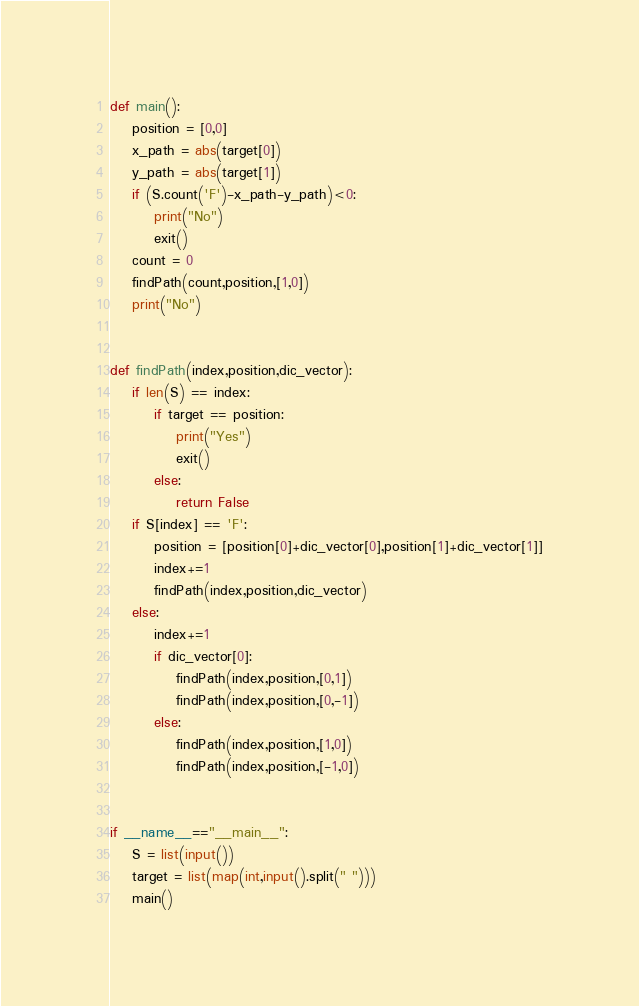Convert code to text. <code><loc_0><loc_0><loc_500><loc_500><_Python_>def main():
    position = [0,0]
    x_path = abs(target[0])
    y_path = abs(target[1])
    if (S.count('F')-x_path-y_path)<0:
        print("No")
        exit()
    count = 0
    findPath(count,position,[1,0])
    print("No")


def findPath(index,position,dic_vector):
    if len(S) == index:
        if target == position:
            print("Yes")
            exit()
        else:
            return False
    if S[index] == 'F':
        position = [position[0]+dic_vector[0],position[1]+dic_vector[1]]
        index+=1
        findPath(index,position,dic_vector)
    else:
        index+=1
        if dic_vector[0]:
            findPath(index,position,[0,1])
            findPath(index,position,[0,-1])
        else:
            findPath(index,position,[1,0])
            findPath(index,position,[-1,0])


if __name__=="__main__":
    S = list(input())
    target = list(map(int,input().split(" ")))
    main()</code> 